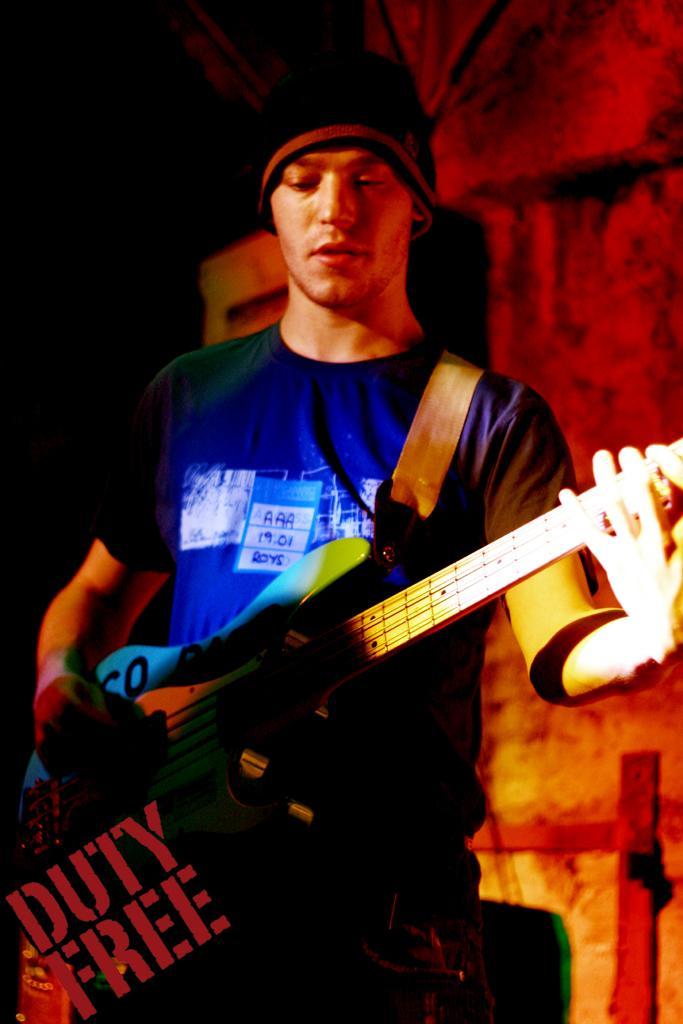Describe this image in one or two sentences. The man in blue t-shirt is playing a guitar. 